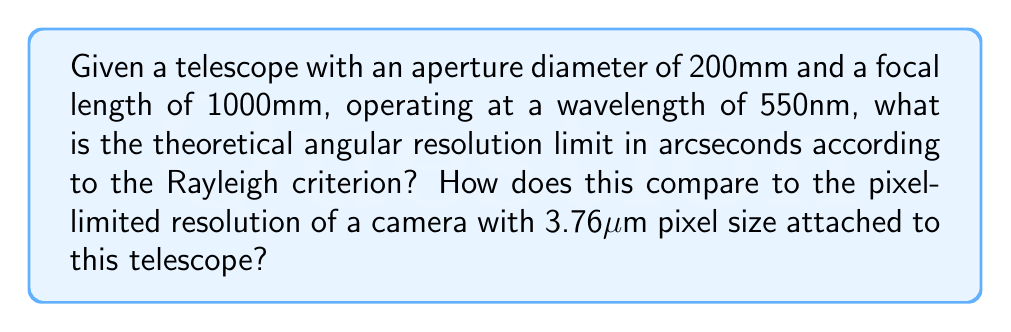Help me with this question. Let's approach this step-by-step:

1) The Rayleigh criterion for angular resolution is given by:

   $$ \theta = 1.22 \frac{\lambda}{D} $$

   where $\theta$ is the angular resolution in radians, $\lambda$ is the wavelength, and $D$ is the aperture diameter.

2) Given values:
   - Aperture diameter, $D = 200\text{mm} = 0.2\text{m}$
   - Wavelength, $\lambda = 550\text{nm} = 5.5 \times 10^{-7}\text{m}$

3) Plugging these into the equation:

   $$ \theta = 1.22 \frac{5.5 \times 10^{-7}}{0.2} = 3.355 \times 10^{-6} \text{ radians} $$

4) To convert to arcseconds, multiply by $\frac{180}{\pi} \times 3600$:

   $$ \theta_{\text{arcsec}} = 3.355 \times 10^{-6} \times \frac{180}{\pi} \times 3600 = 0.692 \text{ arcseconds} $$

5) For the pixel-limited resolution:
   - Pixel size = 3.76μm
   - Focal length = 1000mm

6) The pixel scale is:

   $$ \text{Pixel scale} = \frac{\text{Pixel size}}{\text{Focal length}} = \frac{3.76 \times 10^{-6}}{1} = 3.76 \times 10^{-6} \text{ radians/pixel} $$

7) Converting to arcseconds:

   $$ 3.76 \times 10^{-6} \times \frac{180}{\pi} \times 3600 = 0.775 \text{ arcseconds/pixel} $$

8) The pixel-limited resolution is slightly worse than the theoretical limit, meaning the optical system is not fully utilizing the telescope's potential resolution.
Answer: Theoretical angular resolution: 0.692 arcseconds. Pixel-limited resolution: 0.775 arcseconds/pixel. 